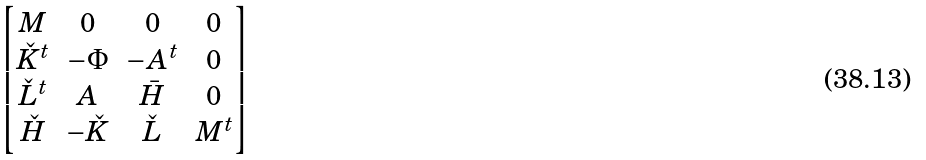<formula> <loc_0><loc_0><loc_500><loc_500>\begin{bmatrix} M & 0 & 0 & 0 \\ \check { K } ^ { t } & - \Phi & - A ^ { t } & 0 \\ \check { L } ^ { t } & A & \bar { H } & 0 \\ \check { H } & - \check { K } & \check { L } & M ^ { t } \end{bmatrix}</formula> 